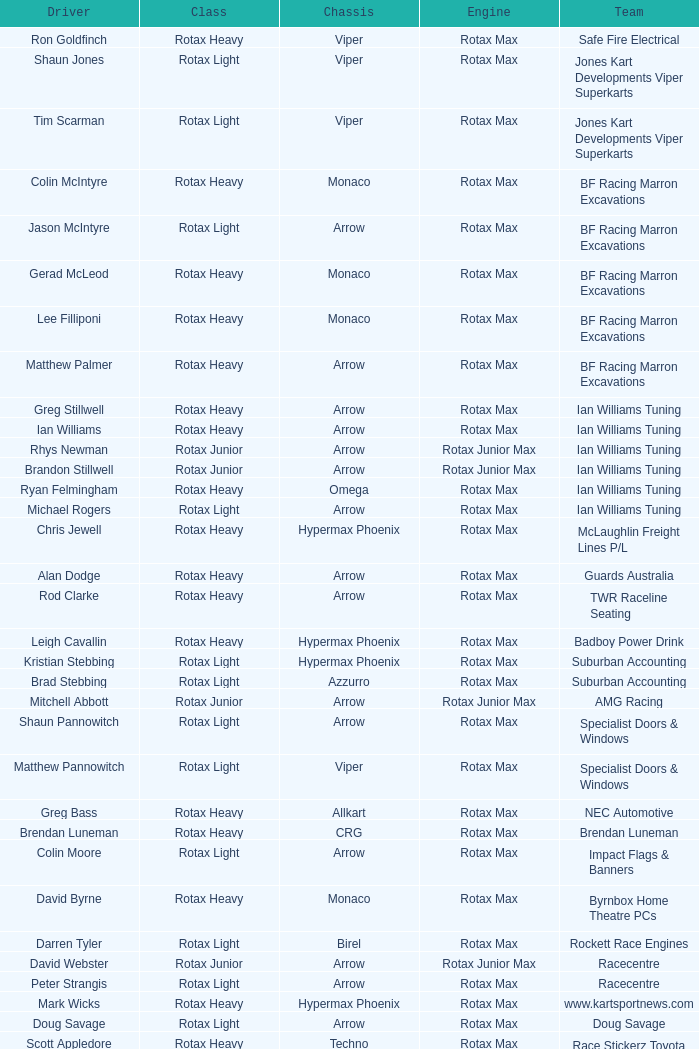What is the name of the team whose class is Rotax Light? Jones Kart Developments Viper Superkarts, Jones Kart Developments Viper Superkarts, BF Racing Marron Excavations, Ian Williams Tuning, Suburban Accounting, Suburban Accounting, Specialist Doors & Windows, Specialist Doors & Windows, Impact Flags & Banners, Rockett Race Engines, Racecentre, Doug Savage. 